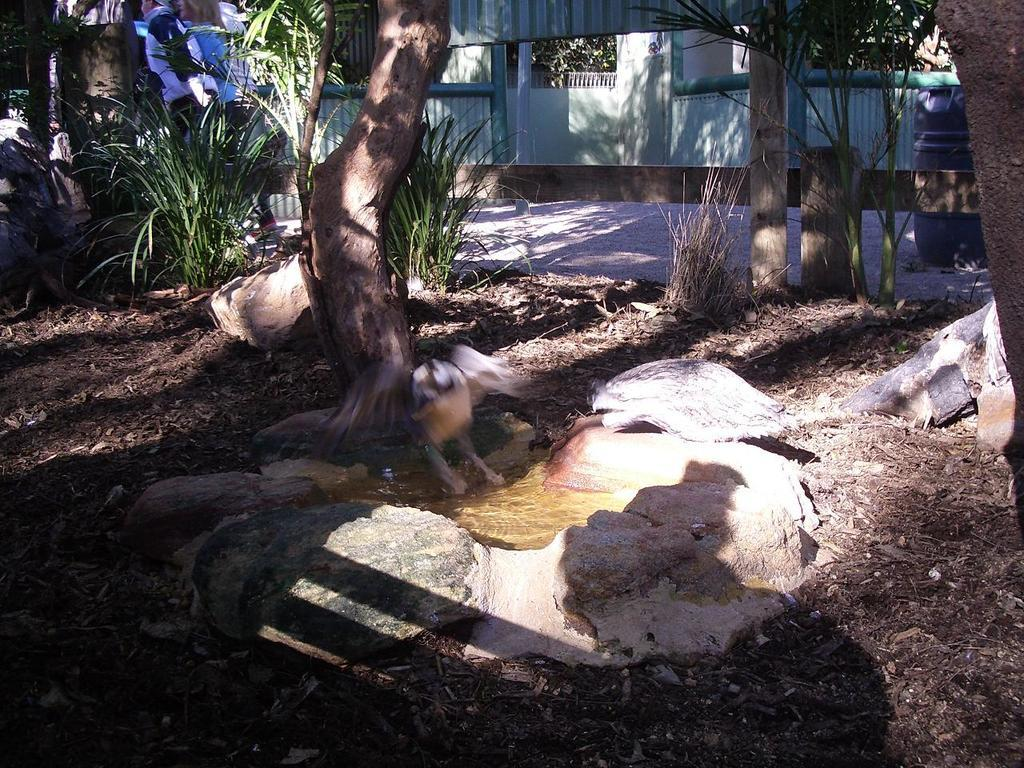What type of living organisms can be seen in the image? Plants can be seen in the image. What can be found on the ground in the image? There are stones on the ground in the image. What is visible in the image besides plants and stones? There is water visible in the image. What is the main feature of the tree in the image? There is a tree trunk in the image. What else is present in the image besides plants, stones, and water? There are objects in the image. What can be seen in the background of the image? There are walls, plants, and objects in the background of the image. What type of haircut does the tree trunk have in the image? There is no haircut present in the image, as the tree trunk is a part of a tree and not a person or animal. How many beads can be seen hanging from the plants in the image? There are no beads present in the image; it only features plants, stones, water, a tree trunk, and various objects. 